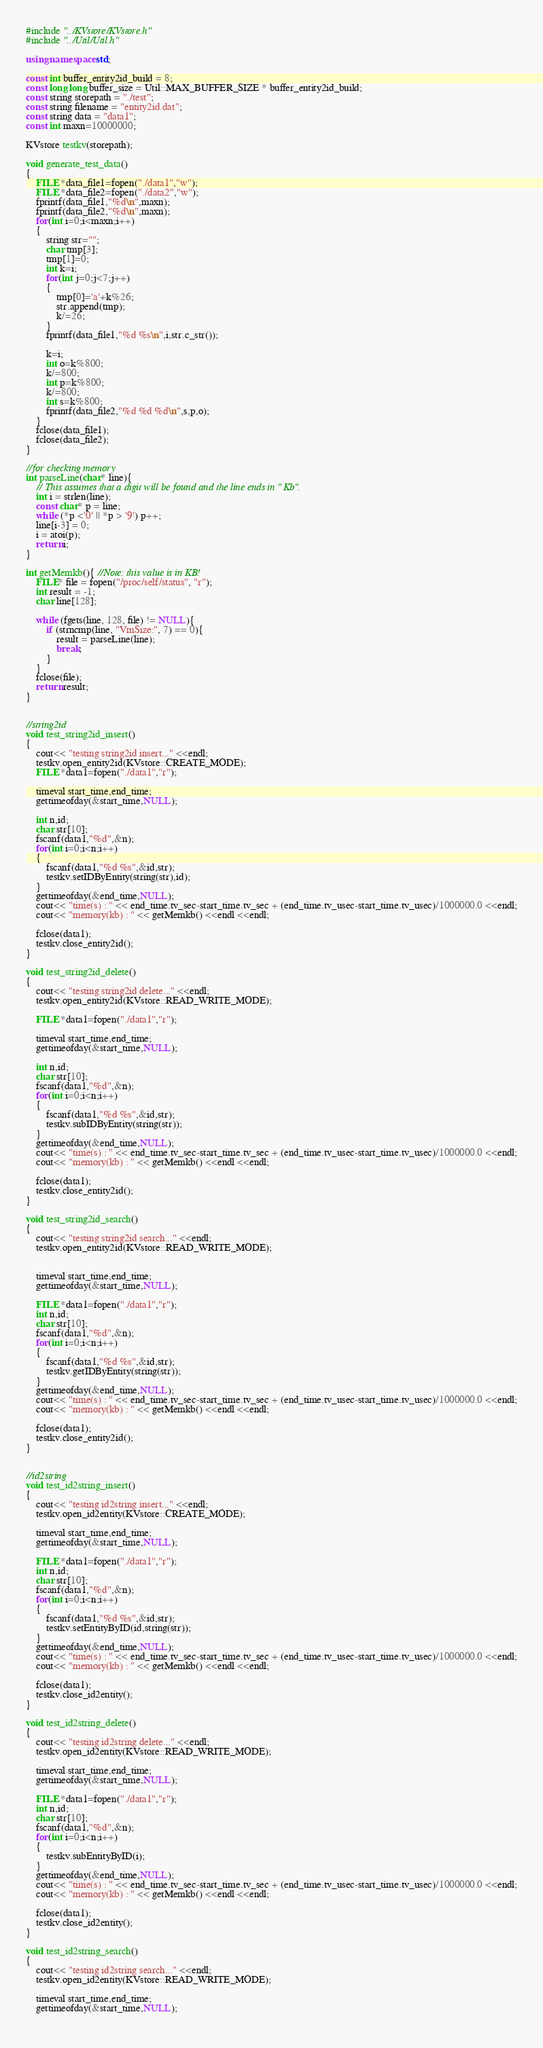Convert code to text. <code><loc_0><loc_0><loc_500><loc_500><_C++_>#include "../KVstore/KVstore.h"
#include "../Util/Util.h"

using namespace std;

const int buffer_entity2id_build = 8;
const long long buffer_size = Util::MAX_BUFFER_SIZE * buffer_entity2id_build;
const string storepath = "./test";
const string filename = "entity2id.dat";
const string data = "data1";
const int maxn=10000000;

KVstore testkv(storepath);

void generate_test_data()
{
	FILE *data_file1=fopen("./data1","w");
	FILE *data_file2=fopen("./data2","w");
	fprintf(data_file1,"%d\n",maxn);
	fprintf(data_file2,"%d\n",maxn);
	for(int i=0;i<maxn;i++)
	{
		string str="";
		char tmp[3];
		tmp[1]=0;
		int k=i;
		for(int j=0;j<7;j++)
		{
			tmp[0]='a'+k%26;
			str.append(tmp);
			k/=26;
		}
		fprintf(data_file1,"%d %s\n",i,str.c_str());
		
		k=i;
		int o=k%800;
		k/=800;
		int p=k%800;
		k/=800;
		int s=k%800;
		fprintf(data_file2,"%d %d %d\n",s,p,o);
	}
	fclose(data_file1);
	fclose(data_file2);
}

//for checking memory
int parseLine(char* line){
    // This assumes that a digit will be found and the line ends in " Kb".
    int i = strlen(line);
    const char* p = line;
    while (*p <'0' || *p > '9') p++;
    line[i-3] = 0;
    i = atoi(p);
    return i;
}

int getMemkb(){ //Note: this value is in KB!
    FILE* file = fopen("/proc/self/status", "r");
    int result = -1;
    char line[128];

    while (fgets(line, 128, file) != NULL){
        if (strncmp(line, "VmSize:", 7) == 0){
            result = parseLine(line);
            break;
        }
    }
    fclose(file);
    return result;
}


//string2id
void test_string2id_insert()
{
	cout<< "testing string2id insert..." <<endl;
	testkv.open_entity2id(KVstore::CREATE_MODE);
	FILE *data1=fopen("./data1","r");
	
	timeval start_time,end_time;
	gettimeofday(&start_time,NULL);
	
	int n,id;
	char str[10];
	fscanf(data1,"%d",&n);
	for(int i=0;i<n;i++)
	{
		fscanf(data1,"%d %s",&id,str);
		testkv.setIDByEntity(string(str),id);
	}
	gettimeofday(&end_time,NULL);
	cout<< "time(s) : " << end_time.tv_sec-start_time.tv_sec + (end_time.tv_usec-start_time.tv_usec)/1000000.0 <<endl;
	cout<< "memory(kb) : " << getMemkb() <<endl <<endl;
	
	fclose(data1);
	testkv.close_entity2id();
}

void test_string2id_delete()
{
	cout<< "testing string2id delete..." <<endl;
	testkv.open_entity2id(KVstore::READ_WRITE_MODE);
	
	FILE *data1=fopen("./data1","r");
	
	timeval start_time,end_time;
	gettimeofday(&start_time,NULL);
	
	int n,id;
	char str[10];
	fscanf(data1,"%d",&n);
	for(int i=0;i<n;i++)
	{
		fscanf(data1,"%d %s",&id,str);
		testkv.subIDByEntity(string(str));
	}
	gettimeofday(&end_time,NULL);
	cout<< "time(s) : " << end_time.tv_sec-start_time.tv_sec + (end_time.tv_usec-start_time.tv_usec)/1000000.0 <<endl;
	cout<< "memory(kb) : " << getMemkb() <<endl <<endl;
	
	fclose(data1);
	testkv.close_entity2id();
}

void test_string2id_search()
{
	cout<< "testing string2id search..." <<endl;
	testkv.open_entity2id(KVstore::READ_WRITE_MODE);

	
	timeval start_time,end_time;
	gettimeofday(&start_time,NULL);
	
	FILE *data1=fopen("./data1","r");
	int n,id;
	char str[10];
	fscanf(data1,"%d",&n);
	for(int i=0;i<n;i++)
	{
		fscanf(data1,"%d %s",&id,str);
		testkv.getIDByEntity(string(str));
	}
	gettimeofday(&end_time,NULL);
	cout<< "time(s) : " << end_time.tv_sec-start_time.tv_sec + (end_time.tv_usec-start_time.tv_usec)/1000000.0 <<endl;
	cout<< "memory(kb) : " << getMemkb() <<endl <<endl;
	
	fclose(data1);
	testkv.close_entity2id();
}


//id2string
void test_id2string_insert()
{
	cout<< "testing id2string insert..." <<endl;
	testkv.open_id2entity(KVstore::CREATE_MODE);
	
	timeval start_time,end_time;
	gettimeofday(&start_time,NULL);
	
	FILE *data1=fopen("./data1","r");
	int n,id;
	char str[10];
	fscanf(data1,"%d",&n);
	for(int i=0;i<n;i++)
	{
		fscanf(data1,"%d %s",&id,str);
		testkv.setEntityByID(id,string(str));
	}
	gettimeofday(&end_time,NULL);
	cout<< "time(s) : " << end_time.tv_sec-start_time.tv_sec + (end_time.tv_usec-start_time.tv_usec)/1000000.0 <<endl;
	cout<< "memory(kb) : " << getMemkb() <<endl <<endl;
	
	fclose(data1);
	testkv.close_id2entity();
}

void test_id2string_delete()
{
	cout<< "testing id2string delete..." <<endl;
	testkv.open_id2entity(KVstore::READ_WRITE_MODE);
	
	timeval start_time,end_time;
	gettimeofday(&start_time,NULL);
	
	FILE *data1=fopen("./data1","r");
	int n,id;
	char str[10];
	fscanf(data1,"%d",&n);
	for(int i=0;i<n;i++)
	{
		testkv.subEntityByID(i);
	}
	gettimeofday(&end_time,NULL);
	cout<< "time(s) : " << end_time.tv_sec-start_time.tv_sec + (end_time.tv_usec-start_time.tv_usec)/1000000.0 <<endl;
	cout<< "memory(kb) : " << getMemkb() <<endl <<endl;
	
	fclose(data1);
	testkv.close_id2entity();
}

void test_id2string_search()
{
	cout<< "testing id2string search..." <<endl;
	testkv.open_id2entity(KVstore::READ_WRITE_MODE);
	
	timeval start_time,end_time;
	gettimeofday(&start_time,NULL);
	</code> 